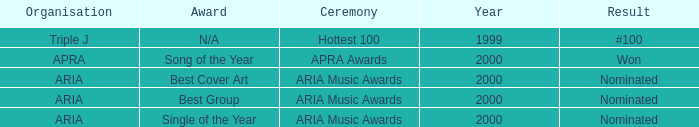What were the results before the year 2000? #100. 